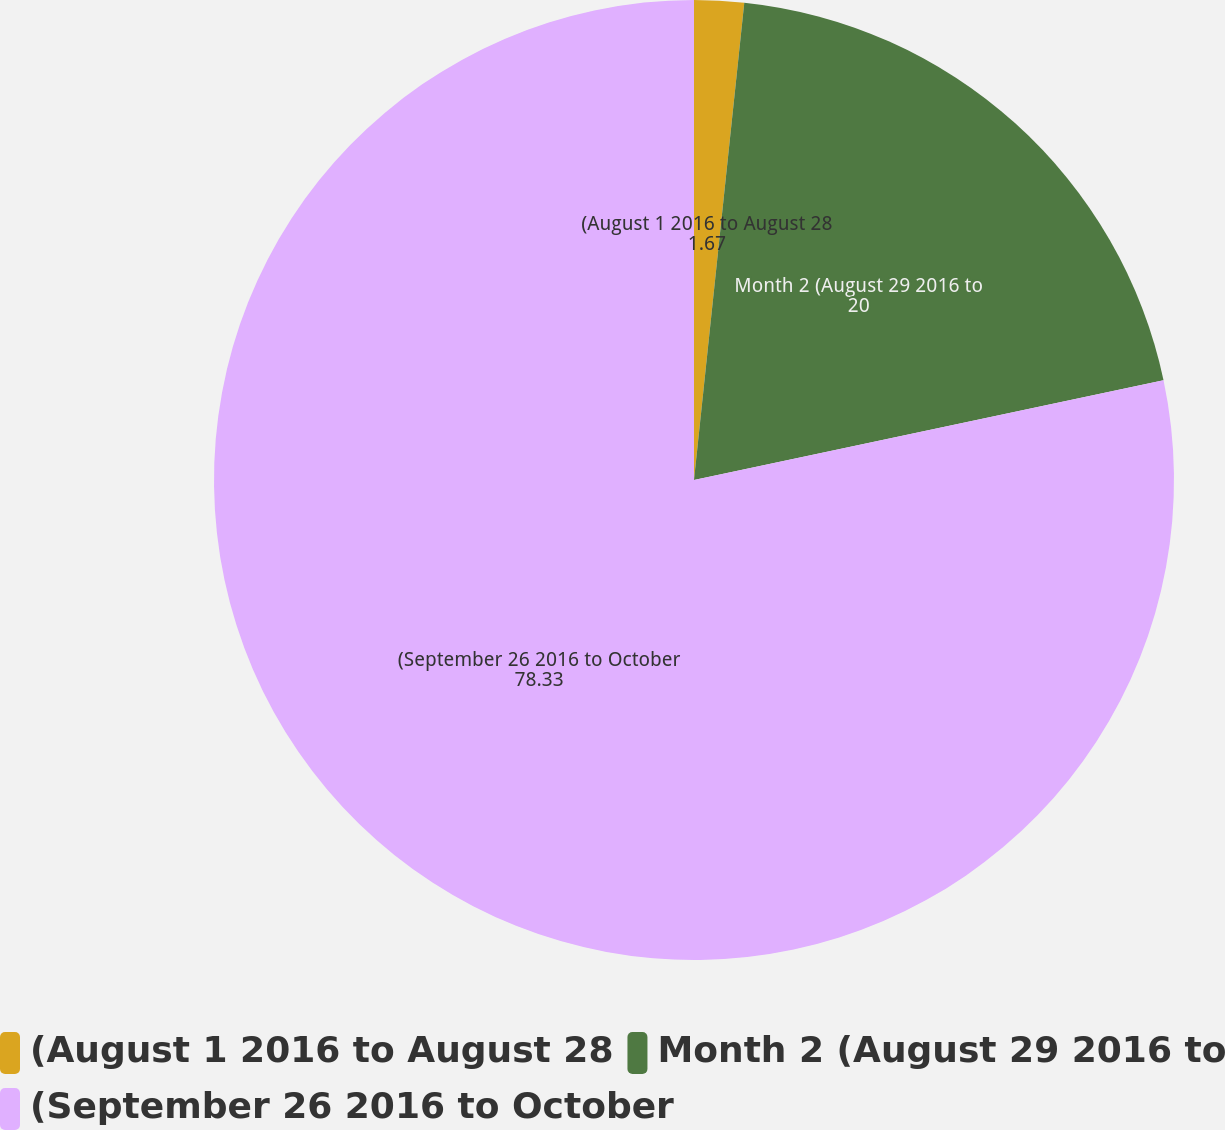<chart> <loc_0><loc_0><loc_500><loc_500><pie_chart><fcel>(August 1 2016 to August 28<fcel>Month 2 (August 29 2016 to<fcel>(September 26 2016 to October<nl><fcel>1.67%<fcel>20.0%<fcel>78.33%<nl></chart> 